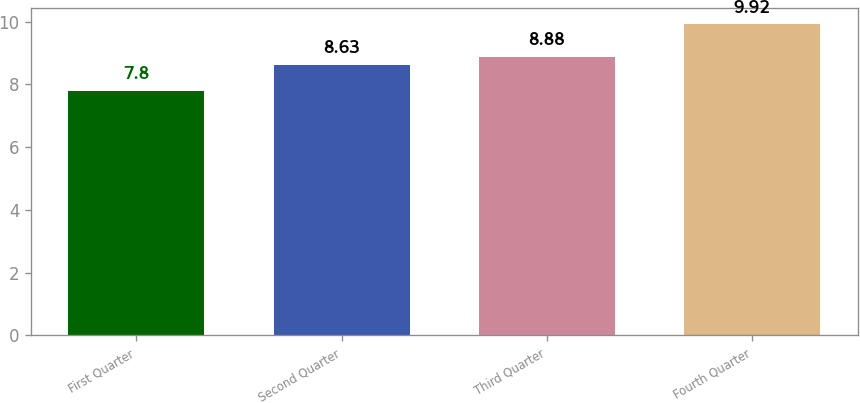Convert chart to OTSL. <chart><loc_0><loc_0><loc_500><loc_500><bar_chart><fcel>First Quarter<fcel>Second Quarter<fcel>Third Quarter<fcel>Fourth Quarter<nl><fcel>7.8<fcel>8.63<fcel>8.88<fcel>9.92<nl></chart> 